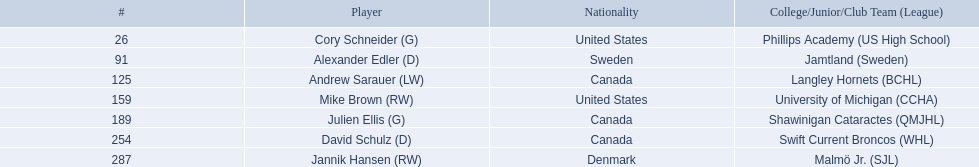Which players have canadian nationality? Andrew Sarauer (LW), Julien Ellis (G), David Schulz (D). Of those, which attended langley hornets? Andrew Sarauer (LW). 